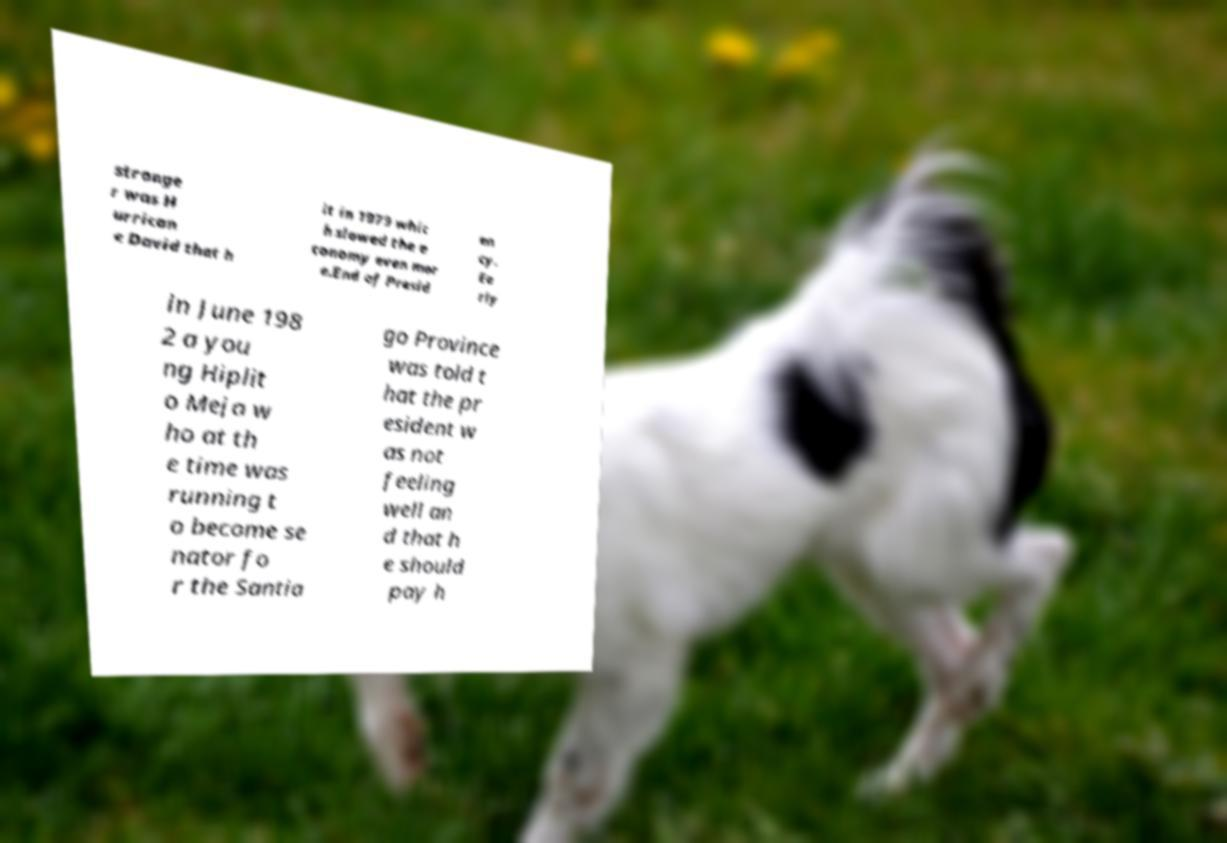For documentation purposes, I need the text within this image transcribed. Could you provide that? stronge r was H urrican e David that h it in 1979 whic h slowed the e conomy even mor e.End of Presid en cy. Ea rly in June 198 2 a you ng Hiplit o Meja w ho at th e time was running t o become se nator fo r the Santia go Province was told t hat the pr esident w as not feeling well an d that h e should pay h 